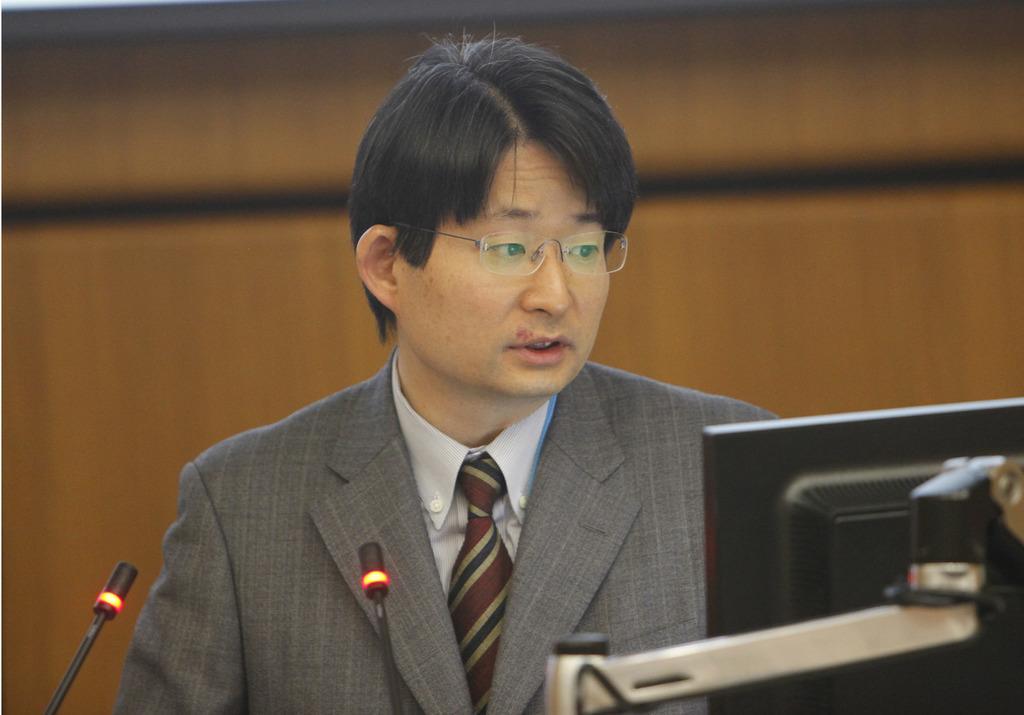In one or two sentences, can you explain what this image depicts? The man in a white shirt and grey blazer who is wearing spectacles is trying to talk something. In front of him, we see microphones and a monitor. He is looking at the monitor. Behind him, we see a brown wall. It is blurred in the background. 